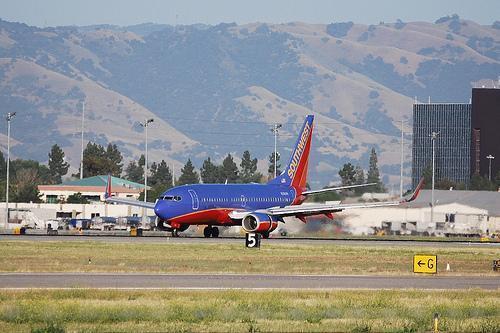How many bodies of water do you see?
Give a very brief answer. 0. 